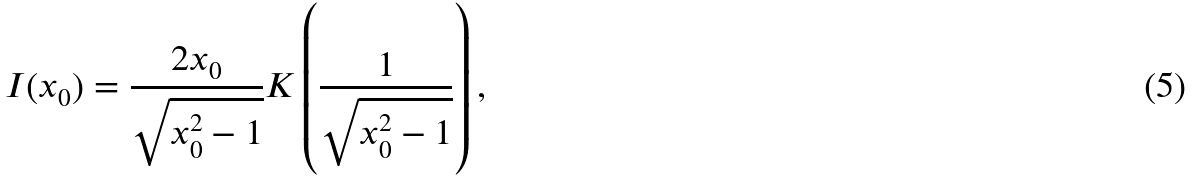Convert formula to latex. <formula><loc_0><loc_0><loc_500><loc_500>I ( x _ { 0 } ) = \frac { 2 x _ { 0 } } { \sqrt { x _ { 0 } ^ { 2 } - 1 } } K \left ( \frac { 1 } { \sqrt { x _ { 0 } ^ { 2 } - 1 } } \right ) ,</formula> 